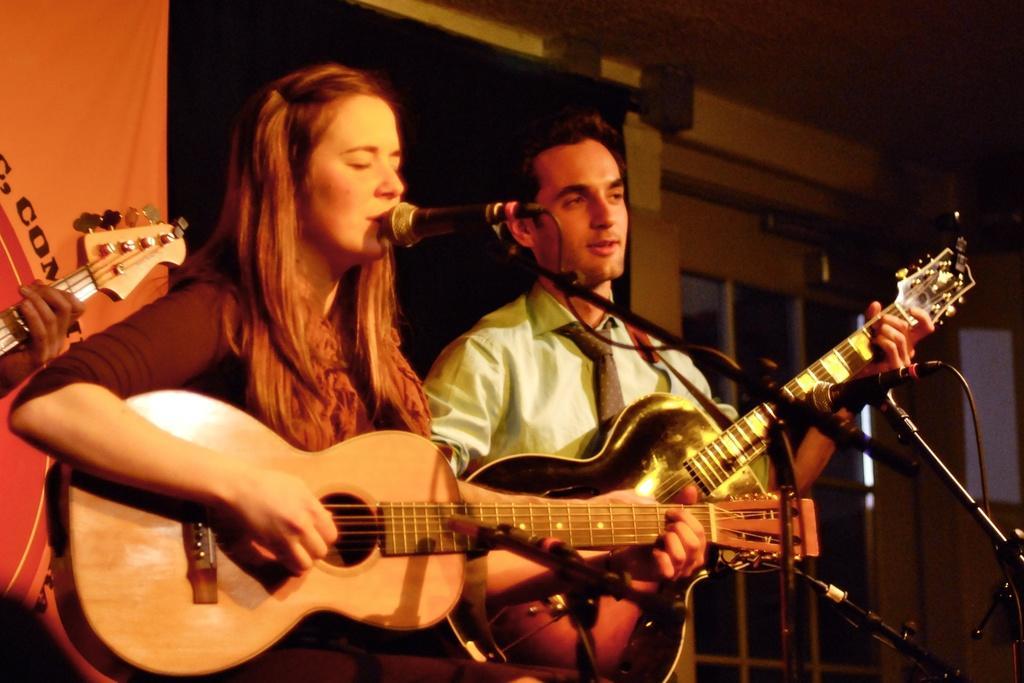In one or two sentences, can you explain what this image depicts? There is a man and woman holding guitar and playing. Woman is singing song. In front of them there are mics with mic stands. In the back there is a banner. Also there are windows. 